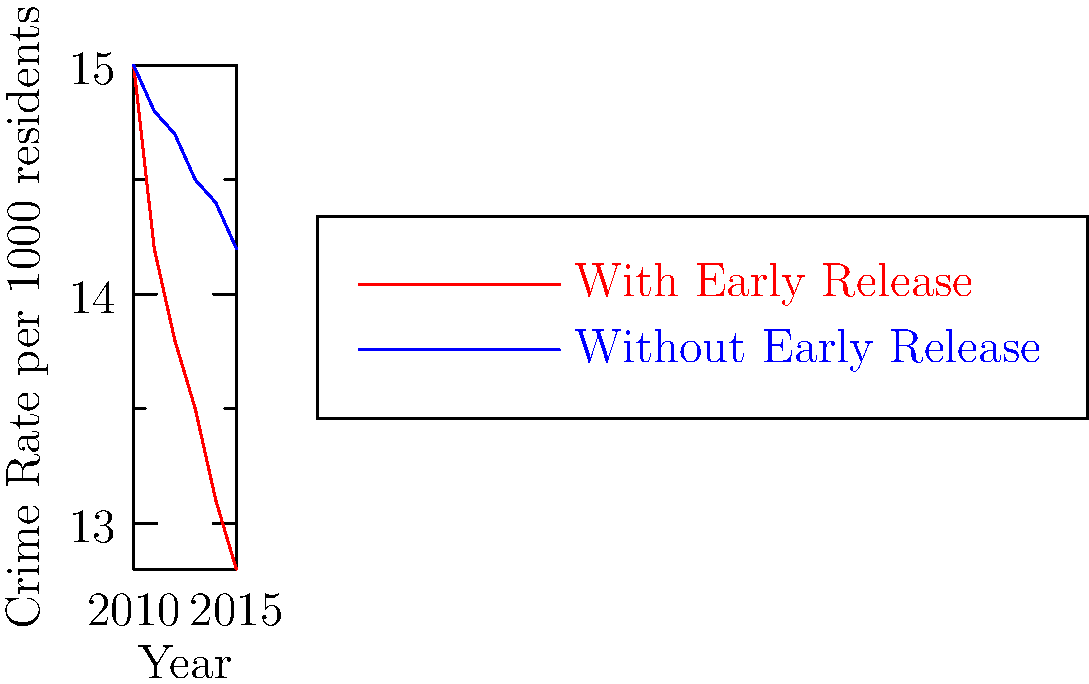Based on the line graph showing crime rates in areas with and without early release programs, calculate the percentage difference in crime rates between the two groups in 2015. How does this data support or challenge the effectiveness of early release programs in reducing crime? To answer this question, we need to follow these steps:

1. Identify the crime rates for both groups in 2015:
   - With Early Release: 12.8 per 1000 residents
   - Without Early Release: 14.2 per 1000 residents

2. Calculate the percentage difference:
   $\text{Percentage Difference} = \frac{|\text{Without ER} - \text{With ER}|}{\text{Without ER}} \times 100\%$
   
   $= \frac{|14.2 - 12.8|}{14.2} \times 100\%$
   
   $= \frac{1.4}{14.2} \times 100\%$
   
   $\approx 9.86\%$

3. Interpret the results:
   The crime rate in areas with early release programs is approximately 9.86% lower than in areas without such programs in 2015.

4. Analyze the trend:
   - The graph shows that crime rates have decreased over time in both groups.
   - The decrease is more pronounced in areas with early release programs.
   - The gap between the two groups has widened over time, suggesting a potentially positive effect of early release programs.

5. Consider limitations:
   - This data alone doesn't prove causation; other factors may influence crime rates.
   - The graph doesn't show recidivism rates or the types of crimes committed.
   - Long-term effects beyond 2015 are not represented.

6. Conclusion:
   While the data suggests that areas with early release programs have lower crime rates, it's important to consider other factors and long-term trends before drawing definitive conclusions about the effectiveness of these programs in reducing crime.
Answer: 9.86% lower in early release areas; data suggests potential effectiveness but requires further analysis of other factors and long-term trends. 